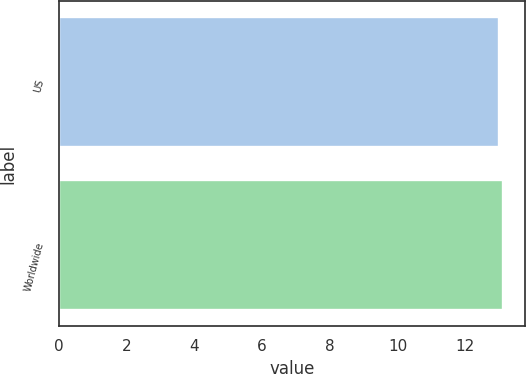<chart> <loc_0><loc_0><loc_500><loc_500><bar_chart><fcel>US<fcel>Worldwide<nl><fcel>13<fcel>13.1<nl></chart> 